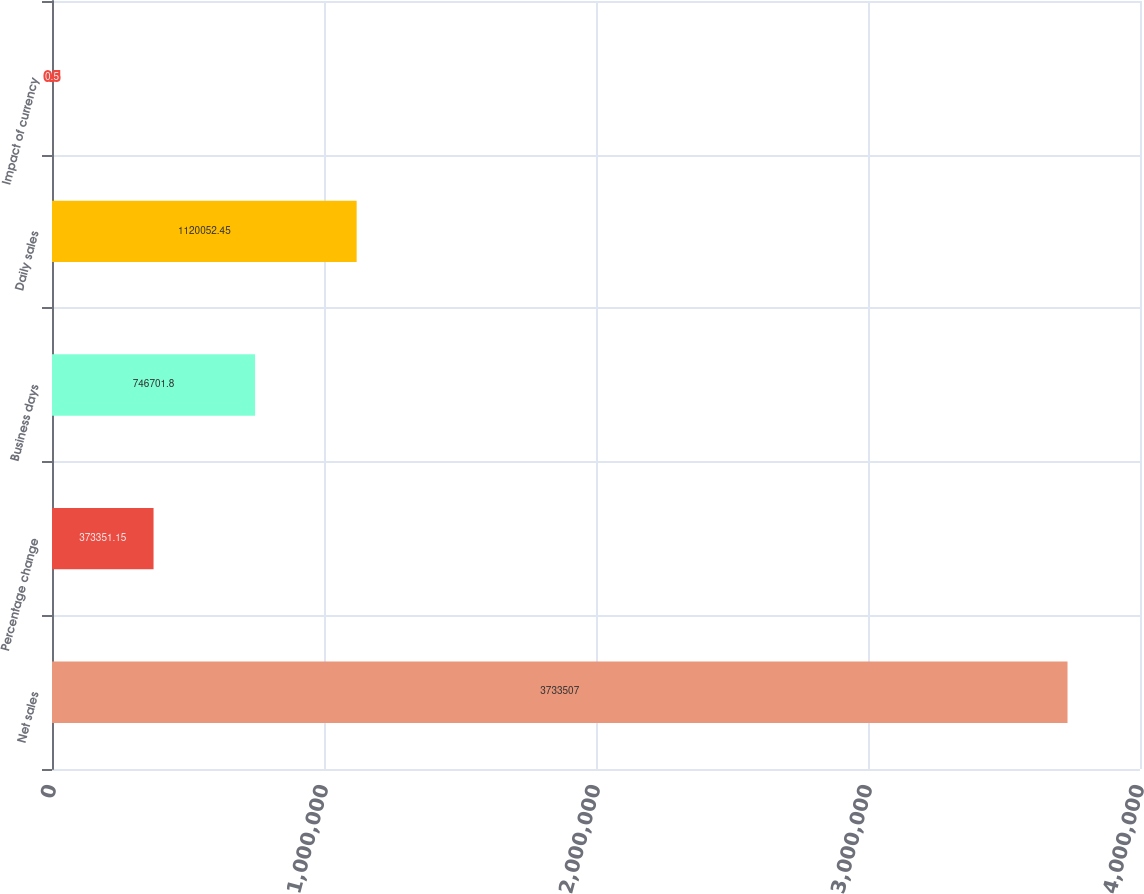Convert chart. <chart><loc_0><loc_0><loc_500><loc_500><bar_chart><fcel>Net sales<fcel>Percentage change<fcel>Business days<fcel>Daily sales<fcel>Impact of currency<nl><fcel>3.73351e+06<fcel>373351<fcel>746702<fcel>1.12005e+06<fcel>0.5<nl></chart> 